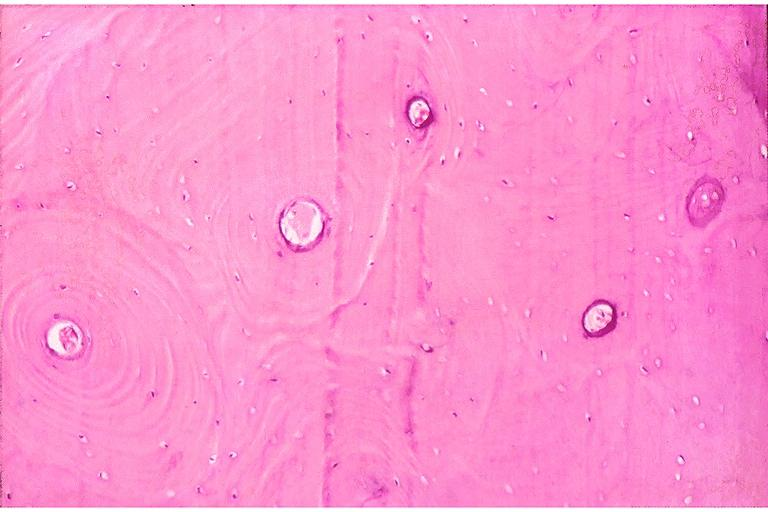where is this?
Answer the question using a single word or phrase. Oral 